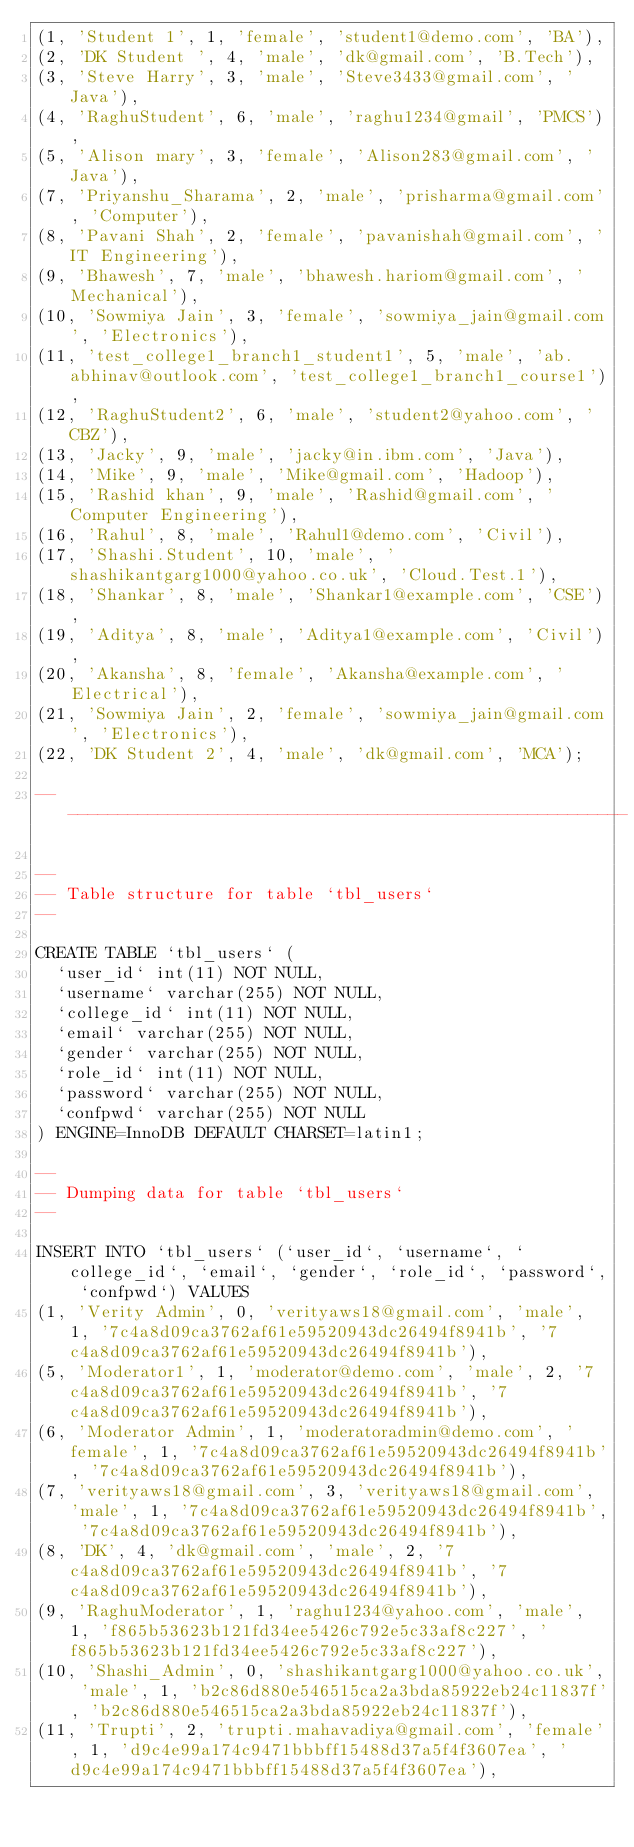Convert code to text. <code><loc_0><loc_0><loc_500><loc_500><_SQL_>(1, 'Student 1', 1, 'female', 'student1@demo.com', 'BA'),
(2, 'DK Student ', 4, 'male', 'dk@gmail.com', 'B.Tech'),
(3, 'Steve Harry', 3, 'male', 'Steve3433@gmail.com', 'Java'),
(4, 'RaghuStudent', 6, 'male', 'raghu1234@gmail', 'PMCS'),
(5, 'Alison mary', 3, 'female', 'Alison283@gmail.com', 'Java'),
(7, 'Priyanshu_Sharama', 2, 'male', 'prisharma@gmail.com', 'Computer'),
(8, 'Pavani Shah', 2, 'female', 'pavanishah@gmail.com', 'IT Engineering'),
(9, 'Bhawesh', 7, 'male', 'bhawesh.hariom@gmail.com', 'Mechanical'),
(10, 'Sowmiya Jain', 3, 'female', 'sowmiya_jain@gmail.com', 'Electronics'),
(11, 'test_college1_branch1_student1', 5, 'male', 'ab.abhinav@outlook.com', 'test_college1_branch1_course1'),
(12, 'RaghuStudent2', 6, 'male', 'student2@yahoo.com', 'CBZ'),
(13, 'Jacky', 9, 'male', 'jacky@in.ibm.com', 'Java'),
(14, 'Mike', 9, 'male', 'Mike@gmail.com', 'Hadoop'),
(15, 'Rashid khan', 9, 'male', 'Rashid@gmail.com', 'Computer Engineering'),
(16, 'Rahul', 8, 'male', 'Rahul1@demo.com', 'Civil'),
(17, 'Shashi.Student', 10, 'male', 'shashikantgarg1000@yahoo.co.uk', 'Cloud.Test.1'),
(18, 'Shankar', 8, 'male', 'Shankar1@example.com', 'CSE'),
(19, 'Aditya', 8, 'male', 'Aditya1@example.com', 'Civil'),
(20, 'Akansha', 8, 'female', 'Akansha@example.com', 'Electrical'),
(21, 'Sowmiya Jain', 2, 'female', 'sowmiya_jain@gmail.com', 'Electronics'),
(22, 'DK Student 2', 4, 'male', 'dk@gmail.com', 'MCA');

-- --------------------------------------------------------

--
-- Table structure for table `tbl_users`
--

CREATE TABLE `tbl_users` (
  `user_id` int(11) NOT NULL,
  `username` varchar(255) NOT NULL,
  `college_id` int(11) NOT NULL,
  `email` varchar(255) NOT NULL,
  `gender` varchar(255) NOT NULL,
  `role_id` int(11) NOT NULL,
  `password` varchar(255) NOT NULL,
  `confpwd` varchar(255) NOT NULL
) ENGINE=InnoDB DEFAULT CHARSET=latin1;

--
-- Dumping data for table `tbl_users`
--

INSERT INTO `tbl_users` (`user_id`, `username`, `college_id`, `email`, `gender`, `role_id`, `password`, `confpwd`) VALUES
(1, 'Verity Admin', 0, 'verityaws18@gmail.com', 'male', 1, '7c4a8d09ca3762af61e59520943dc26494f8941b', '7c4a8d09ca3762af61e59520943dc26494f8941b'),
(5, 'Moderator1', 1, 'moderator@demo.com', 'male', 2, '7c4a8d09ca3762af61e59520943dc26494f8941b', '7c4a8d09ca3762af61e59520943dc26494f8941b'),
(6, 'Moderator Admin', 1, 'moderatoradmin@demo.com', 'female', 1, '7c4a8d09ca3762af61e59520943dc26494f8941b', '7c4a8d09ca3762af61e59520943dc26494f8941b'),
(7, 'verityaws18@gmail.com', 3, 'verityaws18@gmail.com', 'male', 1, '7c4a8d09ca3762af61e59520943dc26494f8941b', '7c4a8d09ca3762af61e59520943dc26494f8941b'),
(8, 'DK', 4, 'dk@gmail.com', 'male', 2, '7c4a8d09ca3762af61e59520943dc26494f8941b', '7c4a8d09ca3762af61e59520943dc26494f8941b'),
(9, 'RaghuModerator', 1, 'raghu1234@yahoo.com', 'male', 1, 'f865b53623b121fd34ee5426c792e5c33af8c227', 'f865b53623b121fd34ee5426c792e5c33af8c227'),
(10, 'Shashi_Admin', 0, 'shashikantgarg1000@yahoo.co.uk', 'male', 1, 'b2c86d880e546515ca2a3bda85922eb24c11837f', 'b2c86d880e546515ca2a3bda85922eb24c11837f'),
(11, 'Trupti', 2, 'trupti.mahavadiya@gmail.com', 'female', 1, 'd9c4e99a174c9471bbbff15488d37a5f4f3607ea', 'd9c4e99a174c9471bbbff15488d37a5f4f3607ea'),</code> 